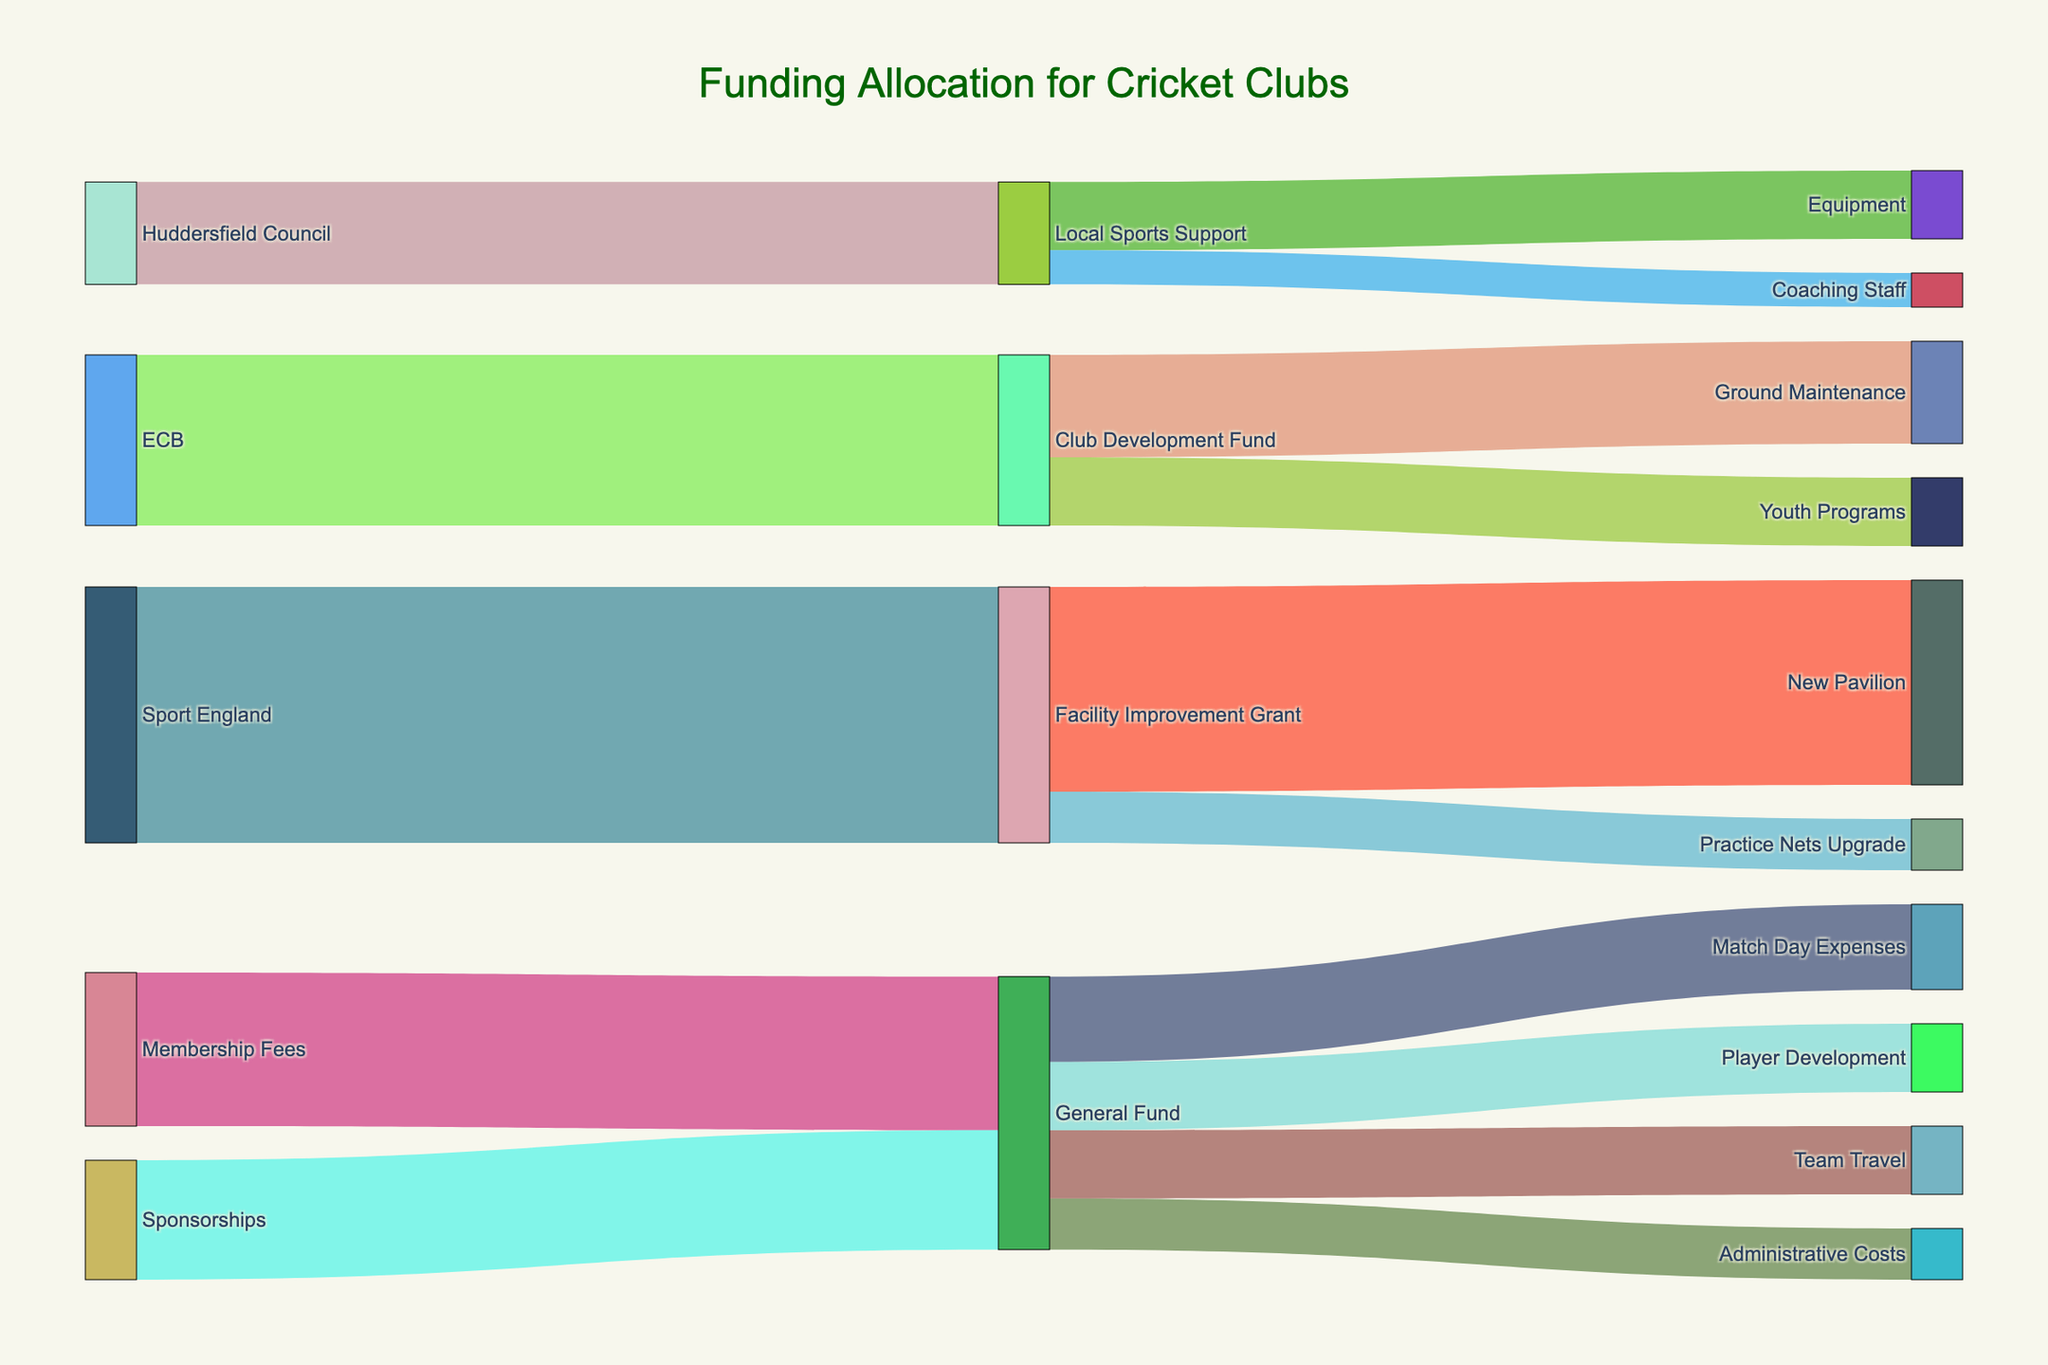Which funding source contributes the most to the Facility Improvement Grant? Look at the amount indicated on the path from each funding source to the Facility Improvement Grant. Sport England contributes 75,000, which is the highest.
Answer: Sport England What is the total amount allocated from the General Fund? Sum up the values coming from the General Fund: Match Day Expenses (25000) + Administrative Costs (15000) + Team Travel (20000) + Player Development (20000) = 80000.
Answer: 80000 How much funding does Huddersfield Council provide in total? Identify the amounts directed from Huddersfield Council: Local Sports Support (30000). This is the total amount.
Answer: 30000 Do Youth Programs receive more or less funding than Player Development? By how much? Youth Programs receive 20000 from the Club Development Fund, and Player Development receives 20000 from the General Fund. Both amounts are equal, so the difference is 0.
Answer: Equal, 0 What is the largest funding allocation category? Compare all the final target categories: Ground Maintenance (30000), Youth Programs (20000), New Pavilion (60000), Practice Nets Upgrade (15000), Equipment (20000), Coaching Staff (10000), Match Day Expenses (25000), Administrative Costs (15000), Team Travel (20000), and Player Development (20000). The New Pavilion allocation of 60000 is the largest.
Answer: New Pavilion Which categories are funded by both the General Fund and another funding source? Identify if any terminal categories have inflows from the General Fund and another source. Only Player Development is funded solely by the General Fund, meaning there are no shared categories.
Answer: None Compare funding allocated to Ground Maintenance and Practice Nets Upgrade. Check the amounts for both: Ground Maintenance receives 30000 and Practice Nets Upgrade receives 15000. Therefore, Ground Maintenance gets more by 15000.
Answer: Ground Maintenance, by 15000 What's the total contribution from Membership Fees and Sponsorships combined? Sum the contributions from Membership Fees (45000) and Sponsorships (35000): 45000 + 35000 = 80000.
Answer: 80000 Which funding source has the smallest contribution? Compare the contributions from all sources: ECB (50000), Sport England (75000), Huddersfield Council (30000), Membership Fees (45000), Sponsorships (35000). Huddersfield Council's 30000 is the smallest.
Answer: Huddersfield Council 